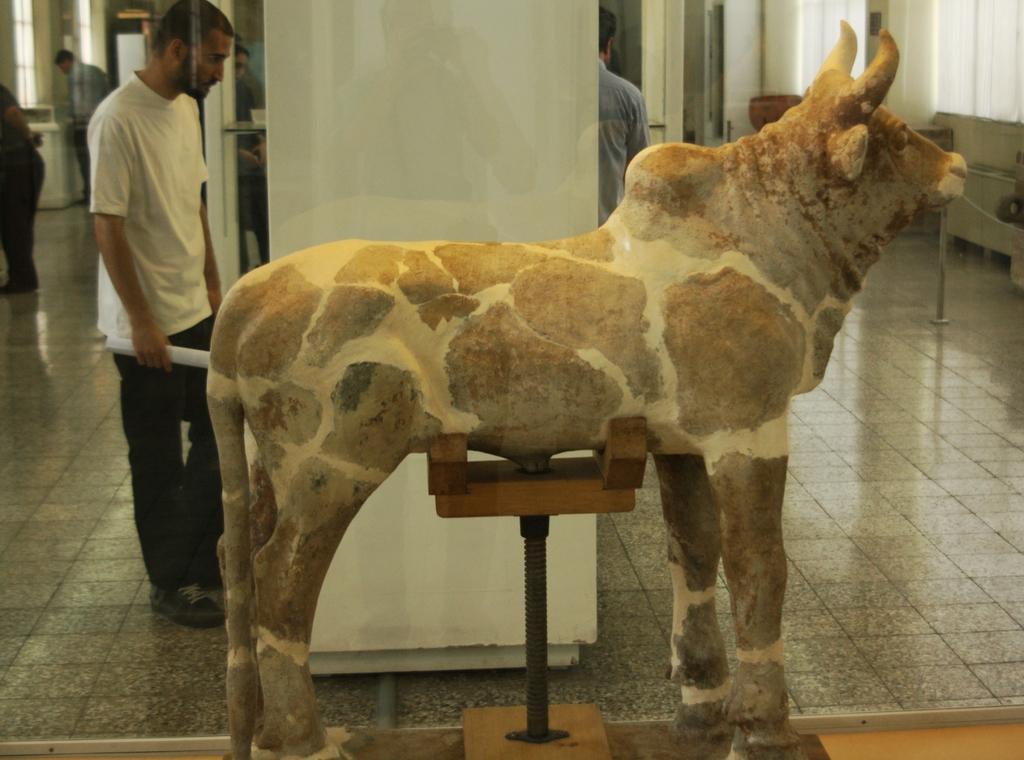Could you give a brief overview of what you see in this image? In this picture, we see the statue of the cow. Beside that, we see a white pillar. The man in white T-shirt is standing beside the pillar. Behind him, we see people standing. On the right side, we see pillars and windows. This picture might be clicked in the museum. 